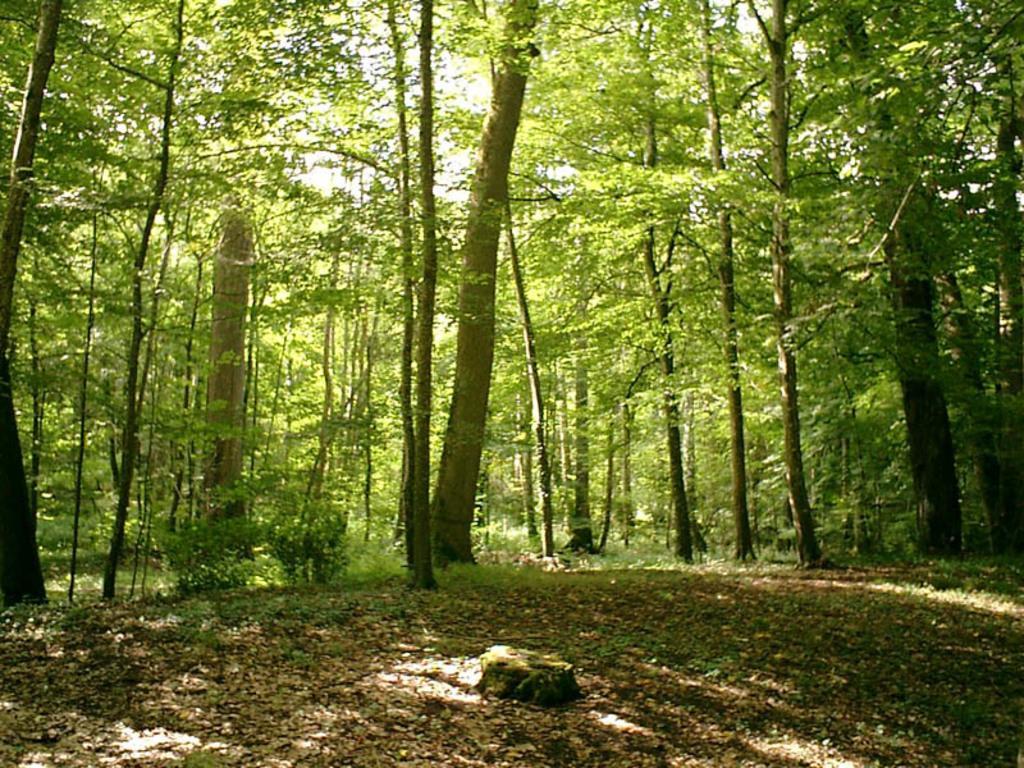Could you give a brief overview of what you see in this image? In this image at the bottom there are some dry leaves and grass, in the background there are a group of trees. 